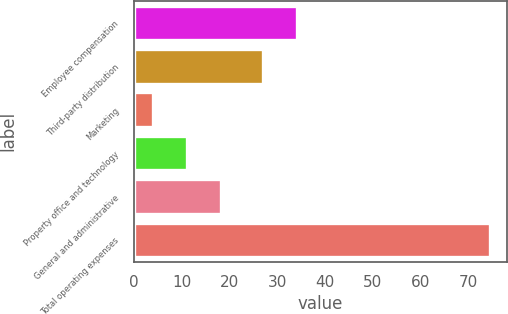Convert chart to OTSL. <chart><loc_0><loc_0><loc_500><loc_500><bar_chart><fcel>Employee compensation<fcel>Third-party distribution<fcel>Marketing<fcel>Property office and technology<fcel>General and administrative<fcel>Total operating expenses<nl><fcel>34.13<fcel>27.1<fcel>4.1<fcel>11.13<fcel>18.16<fcel>74.4<nl></chart> 